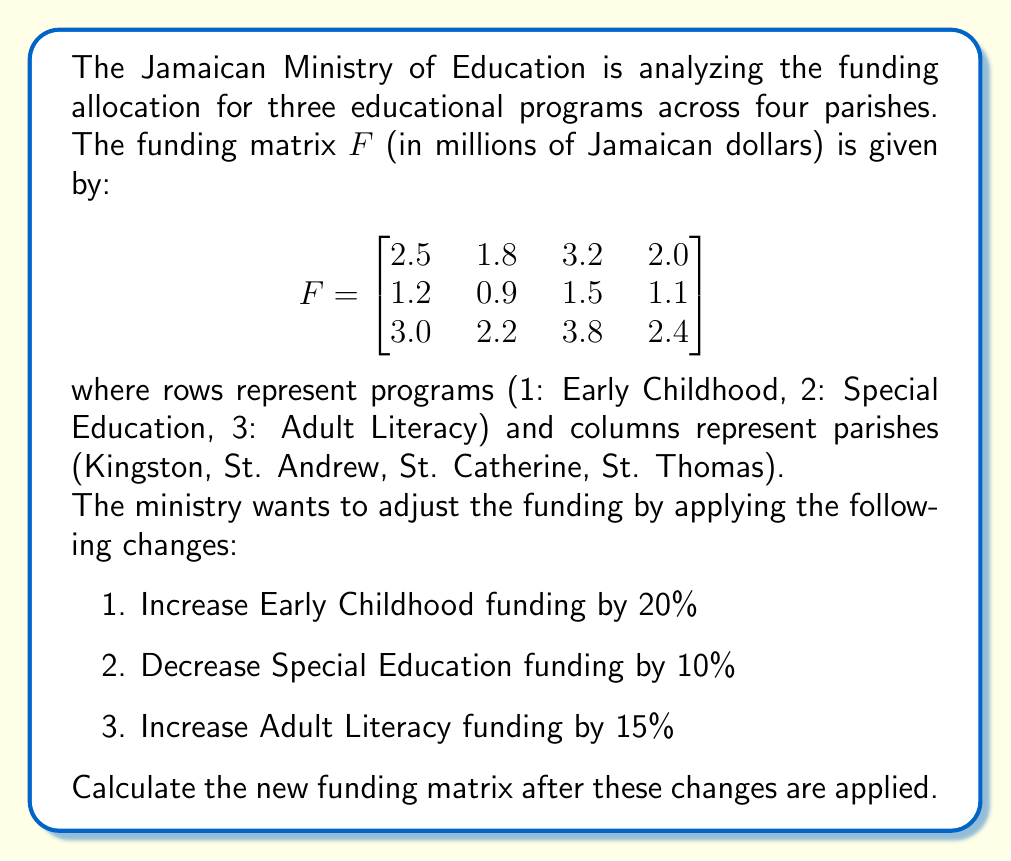Teach me how to tackle this problem. To solve this problem, we need to use matrix multiplication. We'll create a diagonal matrix $D$ that represents the funding changes for each program:

$$D = \begin{bmatrix}
1.20 & 0 & 0 \\
0 & 0.90 & 0 \\
0 & 0 & 1.15
\end{bmatrix}$$

Now, we'll multiply $D$ by $F$ to get the new funding matrix $F_{new}$:

$$F_{new} = D \times F$$

Let's perform the matrix multiplication:

$$\begin{aligned}
F_{new} &= \begin{bmatrix}
1.20 & 0 & 0 \\
0 & 0.90 & 0 \\
0 & 0 & 1.15
\end{bmatrix} \times
\begin{bmatrix}
2.5 & 1.8 & 3.2 & 2.0 \\
1.2 & 0.9 & 1.5 & 1.1 \\
3.0 & 2.2 & 3.8 & 2.4
\end{bmatrix} \\[10pt]
&= \begin{bmatrix}
1.20(2.5) & 1.20(1.8) & 1.20(3.2) & 1.20(2.0) \\
0.90(1.2) & 0.90(0.9) & 0.90(1.5) & 0.90(1.1) \\
1.15(3.0) & 1.15(2.2) & 1.15(3.8) & 1.15(2.4)
\end{bmatrix} \\[10pt]
&= \begin{bmatrix}
3.00 & 2.16 & 3.84 & 2.40 \\
1.08 & 0.81 & 1.35 & 0.99 \\
3.45 & 2.53 & 4.37 & 2.76
\end{bmatrix}
\end{aligned}$$

This resulting matrix $F_{new}$ represents the new funding allocation after applying the specified changes.
Answer: $$F_{new} = \begin{bmatrix}
3.00 & 2.16 & 3.84 & 2.40 \\
1.08 & 0.81 & 1.35 & 0.99 \\
3.45 & 2.53 & 4.37 & 2.76
\end{bmatrix}$$ 